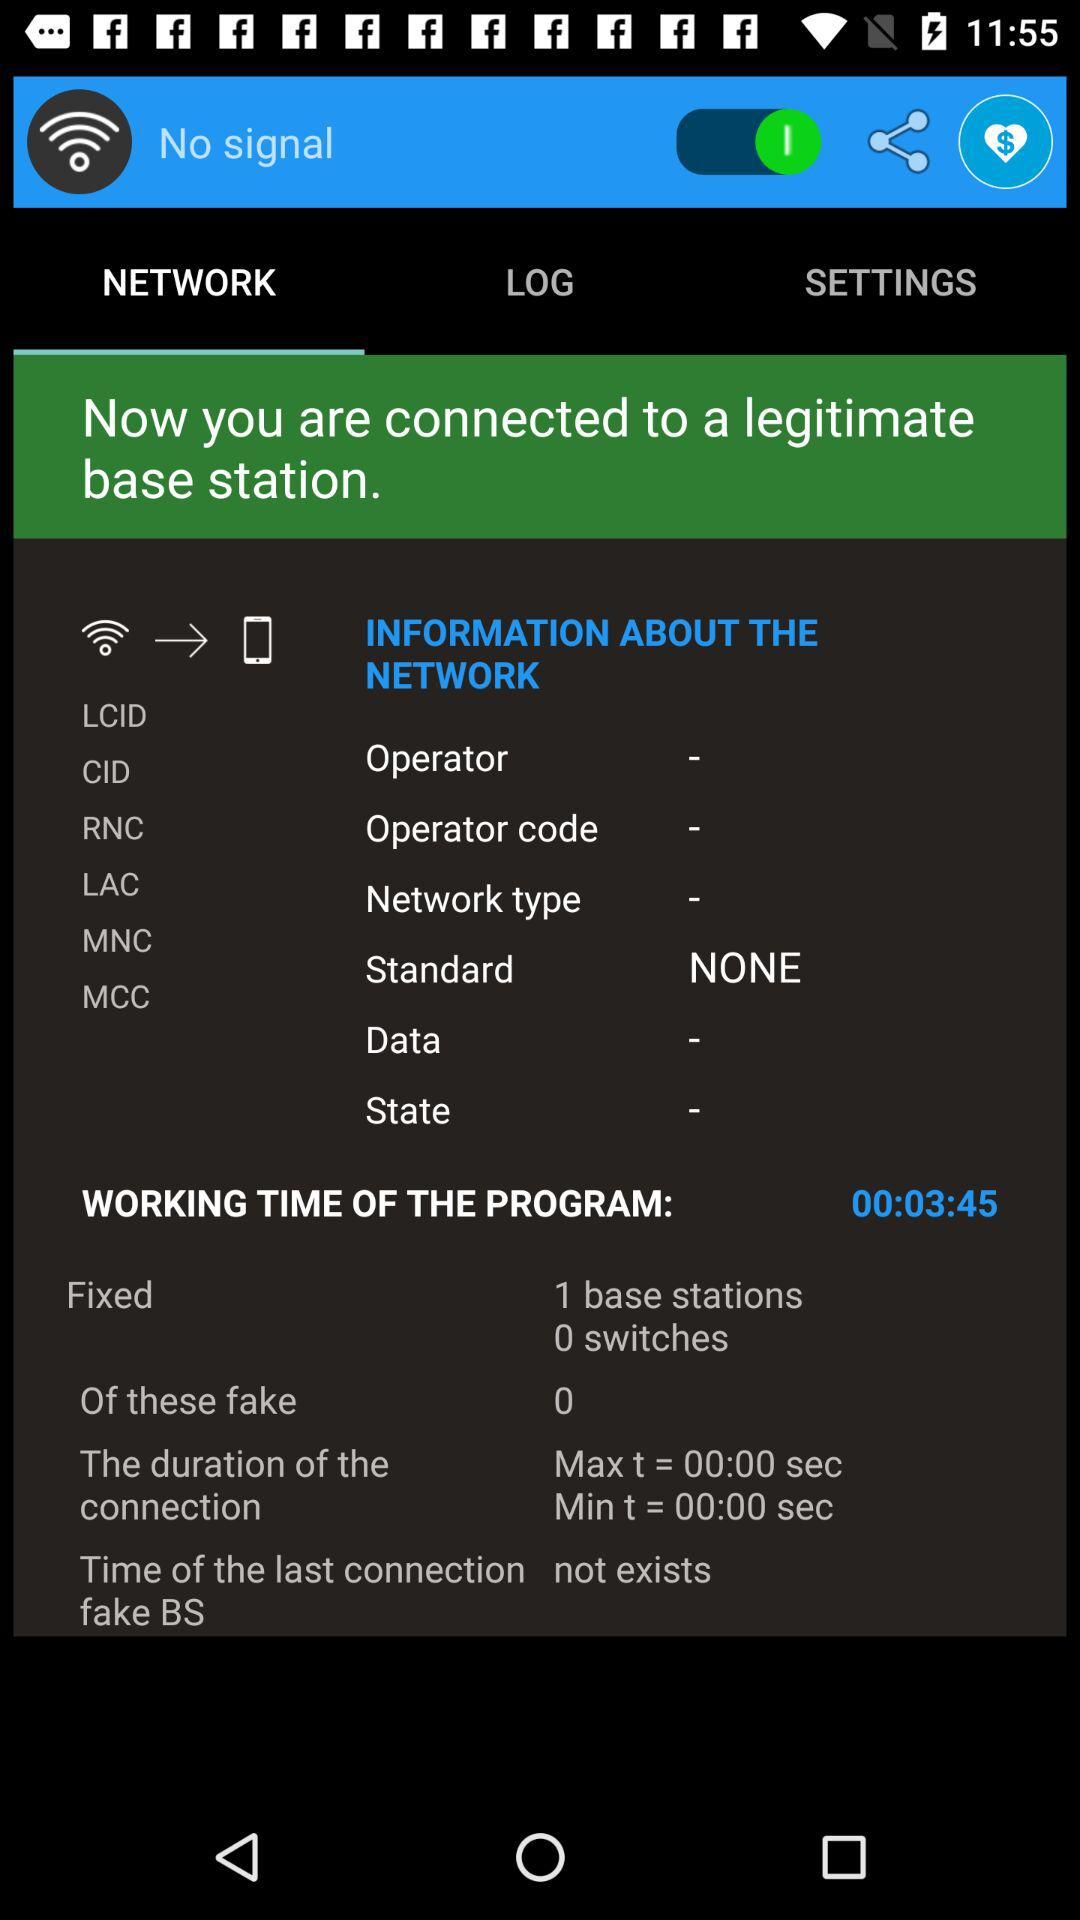What is the time of the last connection? The last connection time is "not exists". 